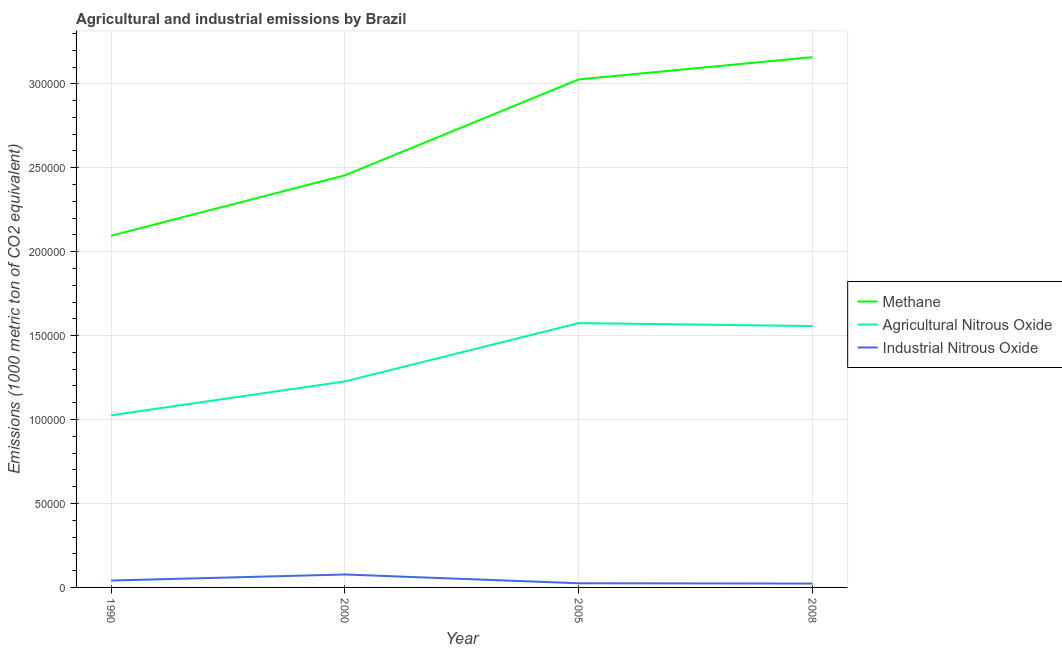How many different coloured lines are there?
Your answer should be very brief. 3. Does the line corresponding to amount of industrial nitrous oxide emissions intersect with the line corresponding to amount of methane emissions?
Provide a succinct answer. No. What is the amount of industrial nitrous oxide emissions in 1990?
Make the answer very short. 4111.4. Across all years, what is the maximum amount of methane emissions?
Provide a short and direct response. 3.16e+05. Across all years, what is the minimum amount of industrial nitrous oxide emissions?
Offer a very short reply. 2306.2. In which year was the amount of methane emissions maximum?
Ensure brevity in your answer.  2008. In which year was the amount of agricultural nitrous oxide emissions minimum?
Keep it short and to the point. 1990. What is the total amount of agricultural nitrous oxide emissions in the graph?
Your answer should be very brief. 5.38e+05. What is the difference between the amount of industrial nitrous oxide emissions in 2005 and that in 2008?
Your response must be concise. 172.3. What is the difference between the amount of methane emissions in 1990 and the amount of agricultural nitrous oxide emissions in 2005?
Offer a very short reply. 5.21e+04. What is the average amount of agricultural nitrous oxide emissions per year?
Make the answer very short. 1.35e+05. In the year 2005, what is the difference between the amount of agricultural nitrous oxide emissions and amount of industrial nitrous oxide emissions?
Offer a terse response. 1.55e+05. What is the ratio of the amount of agricultural nitrous oxide emissions in 2000 to that in 2005?
Offer a terse response. 0.78. Is the amount of agricultural nitrous oxide emissions in 2005 less than that in 2008?
Keep it short and to the point. No. What is the difference between the highest and the second highest amount of methane emissions?
Provide a short and direct response. 1.33e+04. What is the difference between the highest and the lowest amount of agricultural nitrous oxide emissions?
Your answer should be very brief. 5.49e+04. In how many years, is the amount of methane emissions greater than the average amount of methane emissions taken over all years?
Your answer should be very brief. 2. Is the sum of the amount of industrial nitrous oxide emissions in 2000 and 2008 greater than the maximum amount of methane emissions across all years?
Your answer should be very brief. No. Is it the case that in every year, the sum of the amount of methane emissions and amount of agricultural nitrous oxide emissions is greater than the amount of industrial nitrous oxide emissions?
Provide a succinct answer. Yes. Does the amount of industrial nitrous oxide emissions monotonically increase over the years?
Give a very brief answer. No. Is the amount of industrial nitrous oxide emissions strictly less than the amount of agricultural nitrous oxide emissions over the years?
Offer a very short reply. Yes. How many years are there in the graph?
Give a very brief answer. 4. What is the difference between two consecutive major ticks on the Y-axis?
Keep it short and to the point. 5.00e+04. Are the values on the major ticks of Y-axis written in scientific E-notation?
Your answer should be very brief. No. Does the graph contain grids?
Provide a short and direct response. Yes. How many legend labels are there?
Offer a very short reply. 3. How are the legend labels stacked?
Offer a very short reply. Vertical. What is the title of the graph?
Your answer should be compact. Agricultural and industrial emissions by Brazil. What is the label or title of the X-axis?
Offer a terse response. Year. What is the label or title of the Y-axis?
Your answer should be very brief. Emissions (1000 metric ton of CO2 equivalent). What is the Emissions (1000 metric ton of CO2 equivalent) in Methane in 1990?
Your answer should be very brief. 2.10e+05. What is the Emissions (1000 metric ton of CO2 equivalent) in Agricultural Nitrous Oxide in 1990?
Make the answer very short. 1.03e+05. What is the Emissions (1000 metric ton of CO2 equivalent) in Industrial Nitrous Oxide in 1990?
Ensure brevity in your answer.  4111.4. What is the Emissions (1000 metric ton of CO2 equivalent) in Methane in 2000?
Ensure brevity in your answer.  2.45e+05. What is the Emissions (1000 metric ton of CO2 equivalent) in Agricultural Nitrous Oxide in 2000?
Your response must be concise. 1.23e+05. What is the Emissions (1000 metric ton of CO2 equivalent) of Industrial Nitrous Oxide in 2000?
Your answer should be very brief. 7709.7. What is the Emissions (1000 metric ton of CO2 equivalent) in Methane in 2005?
Your answer should be very brief. 3.03e+05. What is the Emissions (1000 metric ton of CO2 equivalent) of Agricultural Nitrous Oxide in 2005?
Provide a short and direct response. 1.57e+05. What is the Emissions (1000 metric ton of CO2 equivalent) in Industrial Nitrous Oxide in 2005?
Ensure brevity in your answer.  2478.5. What is the Emissions (1000 metric ton of CO2 equivalent) in Methane in 2008?
Make the answer very short. 3.16e+05. What is the Emissions (1000 metric ton of CO2 equivalent) of Agricultural Nitrous Oxide in 2008?
Give a very brief answer. 1.56e+05. What is the Emissions (1000 metric ton of CO2 equivalent) in Industrial Nitrous Oxide in 2008?
Provide a short and direct response. 2306.2. Across all years, what is the maximum Emissions (1000 metric ton of CO2 equivalent) of Methane?
Provide a succinct answer. 3.16e+05. Across all years, what is the maximum Emissions (1000 metric ton of CO2 equivalent) in Agricultural Nitrous Oxide?
Provide a succinct answer. 1.57e+05. Across all years, what is the maximum Emissions (1000 metric ton of CO2 equivalent) in Industrial Nitrous Oxide?
Ensure brevity in your answer.  7709.7. Across all years, what is the minimum Emissions (1000 metric ton of CO2 equivalent) in Methane?
Your response must be concise. 2.10e+05. Across all years, what is the minimum Emissions (1000 metric ton of CO2 equivalent) of Agricultural Nitrous Oxide?
Your answer should be very brief. 1.03e+05. Across all years, what is the minimum Emissions (1000 metric ton of CO2 equivalent) in Industrial Nitrous Oxide?
Your response must be concise. 2306.2. What is the total Emissions (1000 metric ton of CO2 equivalent) of Methane in the graph?
Your answer should be very brief. 1.07e+06. What is the total Emissions (1000 metric ton of CO2 equivalent) of Agricultural Nitrous Oxide in the graph?
Your answer should be compact. 5.38e+05. What is the total Emissions (1000 metric ton of CO2 equivalent) in Industrial Nitrous Oxide in the graph?
Your response must be concise. 1.66e+04. What is the difference between the Emissions (1000 metric ton of CO2 equivalent) in Methane in 1990 and that in 2000?
Give a very brief answer. -3.60e+04. What is the difference between the Emissions (1000 metric ton of CO2 equivalent) of Agricultural Nitrous Oxide in 1990 and that in 2000?
Provide a succinct answer. -2.02e+04. What is the difference between the Emissions (1000 metric ton of CO2 equivalent) in Industrial Nitrous Oxide in 1990 and that in 2000?
Make the answer very short. -3598.3. What is the difference between the Emissions (1000 metric ton of CO2 equivalent) in Methane in 1990 and that in 2005?
Your answer should be compact. -9.31e+04. What is the difference between the Emissions (1000 metric ton of CO2 equivalent) in Agricultural Nitrous Oxide in 1990 and that in 2005?
Your answer should be compact. -5.49e+04. What is the difference between the Emissions (1000 metric ton of CO2 equivalent) in Industrial Nitrous Oxide in 1990 and that in 2005?
Offer a terse response. 1632.9. What is the difference between the Emissions (1000 metric ton of CO2 equivalent) in Methane in 1990 and that in 2008?
Provide a succinct answer. -1.06e+05. What is the difference between the Emissions (1000 metric ton of CO2 equivalent) in Agricultural Nitrous Oxide in 1990 and that in 2008?
Ensure brevity in your answer.  -5.32e+04. What is the difference between the Emissions (1000 metric ton of CO2 equivalent) in Industrial Nitrous Oxide in 1990 and that in 2008?
Offer a terse response. 1805.2. What is the difference between the Emissions (1000 metric ton of CO2 equivalent) of Methane in 2000 and that in 2005?
Offer a terse response. -5.71e+04. What is the difference between the Emissions (1000 metric ton of CO2 equivalent) in Agricultural Nitrous Oxide in 2000 and that in 2005?
Offer a very short reply. -3.47e+04. What is the difference between the Emissions (1000 metric ton of CO2 equivalent) in Industrial Nitrous Oxide in 2000 and that in 2005?
Offer a very short reply. 5231.2. What is the difference between the Emissions (1000 metric ton of CO2 equivalent) of Methane in 2000 and that in 2008?
Give a very brief answer. -7.04e+04. What is the difference between the Emissions (1000 metric ton of CO2 equivalent) in Agricultural Nitrous Oxide in 2000 and that in 2008?
Provide a succinct answer. -3.30e+04. What is the difference between the Emissions (1000 metric ton of CO2 equivalent) of Industrial Nitrous Oxide in 2000 and that in 2008?
Keep it short and to the point. 5403.5. What is the difference between the Emissions (1000 metric ton of CO2 equivalent) of Methane in 2005 and that in 2008?
Offer a very short reply. -1.33e+04. What is the difference between the Emissions (1000 metric ton of CO2 equivalent) in Agricultural Nitrous Oxide in 2005 and that in 2008?
Ensure brevity in your answer.  1744.8. What is the difference between the Emissions (1000 metric ton of CO2 equivalent) in Industrial Nitrous Oxide in 2005 and that in 2008?
Provide a short and direct response. 172.3. What is the difference between the Emissions (1000 metric ton of CO2 equivalent) in Methane in 1990 and the Emissions (1000 metric ton of CO2 equivalent) in Agricultural Nitrous Oxide in 2000?
Keep it short and to the point. 8.68e+04. What is the difference between the Emissions (1000 metric ton of CO2 equivalent) in Methane in 1990 and the Emissions (1000 metric ton of CO2 equivalent) in Industrial Nitrous Oxide in 2000?
Give a very brief answer. 2.02e+05. What is the difference between the Emissions (1000 metric ton of CO2 equivalent) of Agricultural Nitrous Oxide in 1990 and the Emissions (1000 metric ton of CO2 equivalent) of Industrial Nitrous Oxide in 2000?
Give a very brief answer. 9.48e+04. What is the difference between the Emissions (1000 metric ton of CO2 equivalent) in Methane in 1990 and the Emissions (1000 metric ton of CO2 equivalent) in Agricultural Nitrous Oxide in 2005?
Offer a terse response. 5.21e+04. What is the difference between the Emissions (1000 metric ton of CO2 equivalent) of Methane in 1990 and the Emissions (1000 metric ton of CO2 equivalent) of Industrial Nitrous Oxide in 2005?
Offer a very short reply. 2.07e+05. What is the difference between the Emissions (1000 metric ton of CO2 equivalent) in Agricultural Nitrous Oxide in 1990 and the Emissions (1000 metric ton of CO2 equivalent) in Industrial Nitrous Oxide in 2005?
Make the answer very short. 1.00e+05. What is the difference between the Emissions (1000 metric ton of CO2 equivalent) of Methane in 1990 and the Emissions (1000 metric ton of CO2 equivalent) of Agricultural Nitrous Oxide in 2008?
Your answer should be very brief. 5.38e+04. What is the difference between the Emissions (1000 metric ton of CO2 equivalent) of Methane in 1990 and the Emissions (1000 metric ton of CO2 equivalent) of Industrial Nitrous Oxide in 2008?
Your answer should be very brief. 2.07e+05. What is the difference between the Emissions (1000 metric ton of CO2 equivalent) of Agricultural Nitrous Oxide in 1990 and the Emissions (1000 metric ton of CO2 equivalent) of Industrial Nitrous Oxide in 2008?
Your answer should be compact. 1.00e+05. What is the difference between the Emissions (1000 metric ton of CO2 equivalent) of Methane in 2000 and the Emissions (1000 metric ton of CO2 equivalent) of Agricultural Nitrous Oxide in 2005?
Offer a terse response. 8.80e+04. What is the difference between the Emissions (1000 metric ton of CO2 equivalent) in Methane in 2000 and the Emissions (1000 metric ton of CO2 equivalent) in Industrial Nitrous Oxide in 2005?
Provide a short and direct response. 2.43e+05. What is the difference between the Emissions (1000 metric ton of CO2 equivalent) of Agricultural Nitrous Oxide in 2000 and the Emissions (1000 metric ton of CO2 equivalent) of Industrial Nitrous Oxide in 2005?
Make the answer very short. 1.20e+05. What is the difference between the Emissions (1000 metric ton of CO2 equivalent) of Methane in 2000 and the Emissions (1000 metric ton of CO2 equivalent) of Agricultural Nitrous Oxide in 2008?
Provide a short and direct response. 8.98e+04. What is the difference between the Emissions (1000 metric ton of CO2 equivalent) in Methane in 2000 and the Emissions (1000 metric ton of CO2 equivalent) in Industrial Nitrous Oxide in 2008?
Your response must be concise. 2.43e+05. What is the difference between the Emissions (1000 metric ton of CO2 equivalent) of Agricultural Nitrous Oxide in 2000 and the Emissions (1000 metric ton of CO2 equivalent) of Industrial Nitrous Oxide in 2008?
Keep it short and to the point. 1.20e+05. What is the difference between the Emissions (1000 metric ton of CO2 equivalent) of Methane in 2005 and the Emissions (1000 metric ton of CO2 equivalent) of Agricultural Nitrous Oxide in 2008?
Keep it short and to the point. 1.47e+05. What is the difference between the Emissions (1000 metric ton of CO2 equivalent) of Methane in 2005 and the Emissions (1000 metric ton of CO2 equivalent) of Industrial Nitrous Oxide in 2008?
Your answer should be very brief. 3.00e+05. What is the difference between the Emissions (1000 metric ton of CO2 equivalent) in Agricultural Nitrous Oxide in 2005 and the Emissions (1000 metric ton of CO2 equivalent) in Industrial Nitrous Oxide in 2008?
Provide a succinct answer. 1.55e+05. What is the average Emissions (1000 metric ton of CO2 equivalent) of Methane per year?
Ensure brevity in your answer.  2.68e+05. What is the average Emissions (1000 metric ton of CO2 equivalent) of Agricultural Nitrous Oxide per year?
Your answer should be compact. 1.35e+05. What is the average Emissions (1000 metric ton of CO2 equivalent) of Industrial Nitrous Oxide per year?
Your answer should be very brief. 4151.45. In the year 1990, what is the difference between the Emissions (1000 metric ton of CO2 equivalent) of Methane and Emissions (1000 metric ton of CO2 equivalent) of Agricultural Nitrous Oxide?
Give a very brief answer. 1.07e+05. In the year 1990, what is the difference between the Emissions (1000 metric ton of CO2 equivalent) in Methane and Emissions (1000 metric ton of CO2 equivalent) in Industrial Nitrous Oxide?
Provide a succinct answer. 2.05e+05. In the year 1990, what is the difference between the Emissions (1000 metric ton of CO2 equivalent) in Agricultural Nitrous Oxide and Emissions (1000 metric ton of CO2 equivalent) in Industrial Nitrous Oxide?
Offer a terse response. 9.84e+04. In the year 2000, what is the difference between the Emissions (1000 metric ton of CO2 equivalent) in Methane and Emissions (1000 metric ton of CO2 equivalent) in Agricultural Nitrous Oxide?
Keep it short and to the point. 1.23e+05. In the year 2000, what is the difference between the Emissions (1000 metric ton of CO2 equivalent) of Methane and Emissions (1000 metric ton of CO2 equivalent) of Industrial Nitrous Oxide?
Your response must be concise. 2.38e+05. In the year 2000, what is the difference between the Emissions (1000 metric ton of CO2 equivalent) in Agricultural Nitrous Oxide and Emissions (1000 metric ton of CO2 equivalent) in Industrial Nitrous Oxide?
Provide a short and direct response. 1.15e+05. In the year 2005, what is the difference between the Emissions (1000 metric ton of CO2 equivalent) of Methane and Emissions (1000 metric ton of CO2 equivalent) of Agricultural Nitrous Oxide?
Offer a very short reply. 1.45e+05. In the year 2005, what is the difference between the Emissions (1000 metric ton of CO2 equivalent) in Methane and Emissions (1000 metric ton of CO2 equivalent) in Industrial Nitrous Oxide?
Give a very brief answer. 3.00e+05. In the year 2005, what is the difference between the Emissions (1000 metric ton of CO2 equivalent) of Agricultural Nitrous Oxide and Emissions (1000 metric ton of CO2 equivalent) of Industrial Nitrous Oxide?
Provide a succinct answer. 1.55e+05. In the year 2008, what is the difference between the Emissions (1000 metric ton of CO2 equivalent) of Methane and Emissions (1000 metric ton of CO2 equivalent) of Agricultural Nitrous Oxide?
Your answer should be compact. 1.60e+05. In the year 2008, what is the difference between the Emissions (1000 metric ton of CO2 equivalent) of Methane and Emissions (1000 metric ton of CO2 equivalent) of Industrial Nitrous Oxide?
Keep it short and to the point. 3.14e+05. In the year 2008, what is the difference between the Emissions (1000 metric ton of CO2 equivalent) of Agricultural Nitrous Oxide and Emissions (1000 metric ton of CO2 equivalent) of Industrial Nitrous Oxide?
Your answer should be compact. 1.53e+05. What is the ratio of the Emissions (1000 metric ton of CO2 equivalent) in Methane in 1990 to that in 2000?
Make the answer very short. 0.85. What is the ratio of the Emissions (1000 metric ton of CO2 equivalent) of Agricultural Nitrous Oxide in 1990 to that in 2000?
Keep it short and to the point. 0.84. What is the ratio of the Emissions (1000 metric ton of CO2 equivalent) of Industrial Nitrous Oxide in 1990 to that in 2000?
Provide a succinct answer. 0.53. What is the ratio of the Emissions (1000 metric ton of CO2 equivalent) in Methane in 1990 to that in 2005?
Offer a very short reply. 0.69. What is the ratio of the Emissions (1000 metric ton of CO2 equivalent) of Agricultural Nitrous Oxide in 1990 to that in 2005?
Provide a succinct answer. 0.65. What is the ratio of the Emissions (1000 metric ton of CO2 equivalent) in Industrial Nitrous Oxide in 1990 to that in 2005?
Your response must be concise. 1.66. What is the ratio of the Emissions (1000 metric ton of CO2 equivalent) of Methane in 1990 to that in 2008?
Your answer should be compact. 0.66. What is the ratio of the Emissions (1000 metric ton of CO2 equivalent) of Agricultural Nitrous Oxide in 1990 to that in 2008?
Provide a succinct answer. 0.66. What is the ratio of the Emissions (1000 metric ton of CO2 equivalent) of Industrial Nitrous Oxide in 1990 to that in 2008?
Provide a short and direct response. 1.78. What is the ratio of the Emissions (1000 metric ton of CO2 equivalent) in Methane in 2000 to that in 2005?
Offer a very short reply. 0.81. What is the ratio of the Emissions (1000 metric ton of CO2 equivalent) in Agricultural Nitrous Oxide in 2000 to that in 2005?
Offer a terse response. 0.78. What is the ratio of the Emissions (1000 metric ton of CO2 equivalent) of Industrial Nitrous Oxide in 2000 to that in 2005?
Make the answer very short. 3.11. What is the ratio of the Emissions (1000 metric ton of CO2 equivalent) of Methane in 2000 to that in 2008?
Your answer should be very brief. 0.78. What is the ratio of the Emissions (1000 metric ton of CO2 equivalent) in Agricultural Nitrous Oxide in 2000 to that in 2008?
Your response must be concise. 0.79. What is the ratio of the Emissions (1000 metric ton of CO2 equivalent) in Industrial Nitrous Oxide in 2000 to that in 2008?
Ensure brevity in your answer.  3.34. What is the ratio of the Emissions (1000 metric ton of CO2 equivalent) of Methane in 2005 to that in 2008?
Your answer should be compact. 0.96. What is the ratio of the Emissions (1000 metric ton of CO2 equivalent) of Agricultural Nitrous Oxide in 2005 to that in 2008?
Ensure brevity in your answer.  1.01. What is the ratio of the Emissions (1000 metric ton of CO2 equivalent) in Industrial Nitrous Oxide in 2005 to that in 2008?
Provide a short and direct response. 1.07. What is the difference between the highest and the second highest Emissions (1000 metric ton of CO2 equivalent) of Methane?
Provide a succinct answer. 1.33e+04. What is the difference between the highest and the second highest Emissions (1000 metric ton of CO2 equivalent) of Agricultural Nitrous Oxide?
Provide a short and direct response. 1744.8. What is the difference between the highest and the second highest Emissions (1000 metric ton of CO2 equivalent) in Industrial Nitrous Oxide?
Your answer should be compact. 3598.3. What is the difference between the highest and the lowest Emissions (1000 metric ton of CO2 equivalent) of Methane?
Your answer should be compact. 1.06e+05. What is the difference between the highest and the lowest Emissions (1000 metric ton of CO2 equivalent) of Agricultural Nitrous Oxide?
Your answer should be compact. 5.49e+04. What is the difference between the highest and the lowest Emissions (1000 metric ton of CO2 equivalent) of Industrial Nitrous Oxide?
Your answer should be compact. 5403.5. 